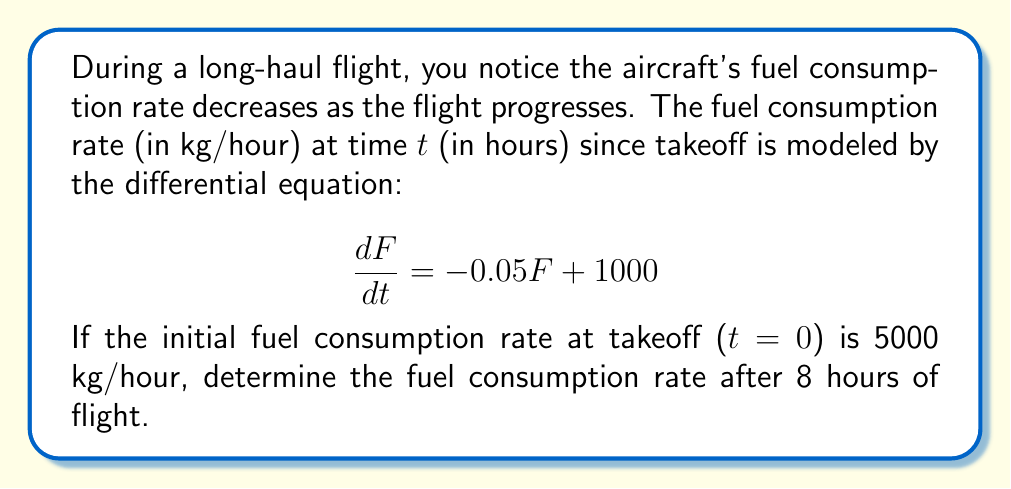Help me with this question. 1) We have a first-order linear differential equation:
   $$\frac{dF}{dt} = -0.05F + 1000$$

2) The general solution for this type of equation is:
   $$F(t) = ce^{-0.05t} + 20000$$
   where c is a constant to be determined from the initial condition.

3) Given the initial condition F(0) = 5000, we can find c:
   $$5000 = c + 20000$$
   $$c = -15000$$

4) Therefore, the particular solution is:
   $$F(t) = -15000e^{-0.05t} + 20000$$

5) To find the fuel consumption rate after 8 hours, we evaluate F(8):
   $$F(8) = -15000e^{-0.05(8)} + 20000$$
   $$F(8) = -15000e^{-0.4} + 20000$$
   $$F(8) = -15000(0.6703) + 20000$$
   $$F(8) = -10054.5 + 20000$$
   $$F(8) = 9945.5$$

6) Rounding to the nearest whole number:
   $$F(8) \approx 9946$$
Answer: 9946 kg/hour 